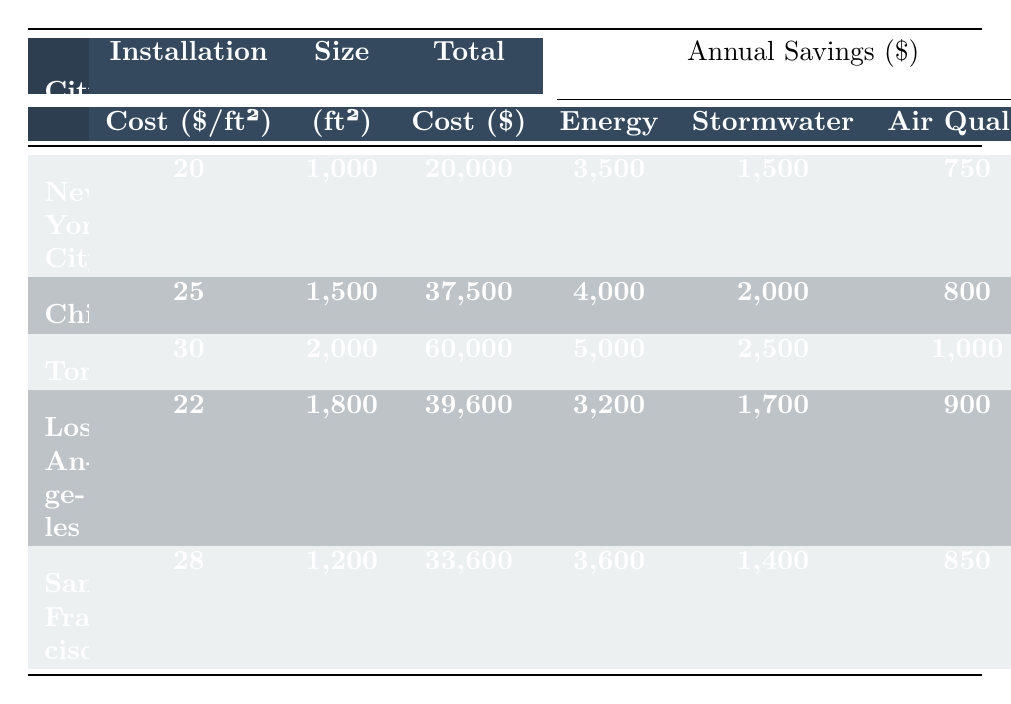What is the Total Installation Cost for Chicago? The table directly lists the Total Installation Cost for Chicago as \$37,500.
Answer: \$37,500 What is the Payback Period for the Green Roof installation in New York City? The Payback Period for New York City is explicitly stated in the table as 4.5 years.
Answer: 4.5 years Which city has the highest Annual Energy Savings? By comparing the Annual Energy Savings across all cities, Toronto shows the highest value at \$5,000.
Answer: Toronto What is the average Installation Cost per Square Foot across all cities? To find the average, sum the installation costs: (20 + 25 + 30 + 22 + 28) = 125, then divide by the number of cities (5): 125 / 5 = 25.
Answer: \$25 Is the Annual Stormwater Management Savings greater in Chicago than in New York City? By comparing the values from the table, Chicago has \$2,000 and New York City has \$1,500 in Annual Stormwater Management Savings, so the statement is true.
Answer: Yes How much more is the Total Installation Cost in Toronto compared to Los Angeles? The Total Installation Cost for Toronto is \$60,000 and for Los Angeles it is \$39,600. The difference is \$60,000 - \$39,600 = \$20,400.
Answer: \$20,400 Which city has the longest Payback Period? The Payback Period for each city is: New York City (4.5), Chicago (5.2), Toronto (5.8), Los Angeles (6.4), and San Francisco (6.0). Los Angeles has the longest period at 6.4 years.
Answer: Los Angeles What is the total Annual Savings for San Francisco? The total Annual Savings for San Francisco is the sum of Energy, Stormwater, and Air Quality Savings: 3,600 + 1,400 + 850 = 5,850.
Answer: \$5,850 What is the percentage difference in Installation Costs between Toronto and New York City? First, find the difference in costs: \$30 (Toronto) - \$20 (New York City) = \$10. Then, divide by New York City's cost: \$10 / \$20 = 0.5, then multiply by 100 for percentage = 50%.
Answer: 50% Which city has the lowest Annual Air Quality Improvement Savings? The Annual Air Quality Improvement Savings are compared: New York City (\$750), Chicago (\$800), Toronto (\$1,000), Los Angeles (\$900), and San Francisco (\$850). New York City has the lowest at \$750.
Answer: New York City 